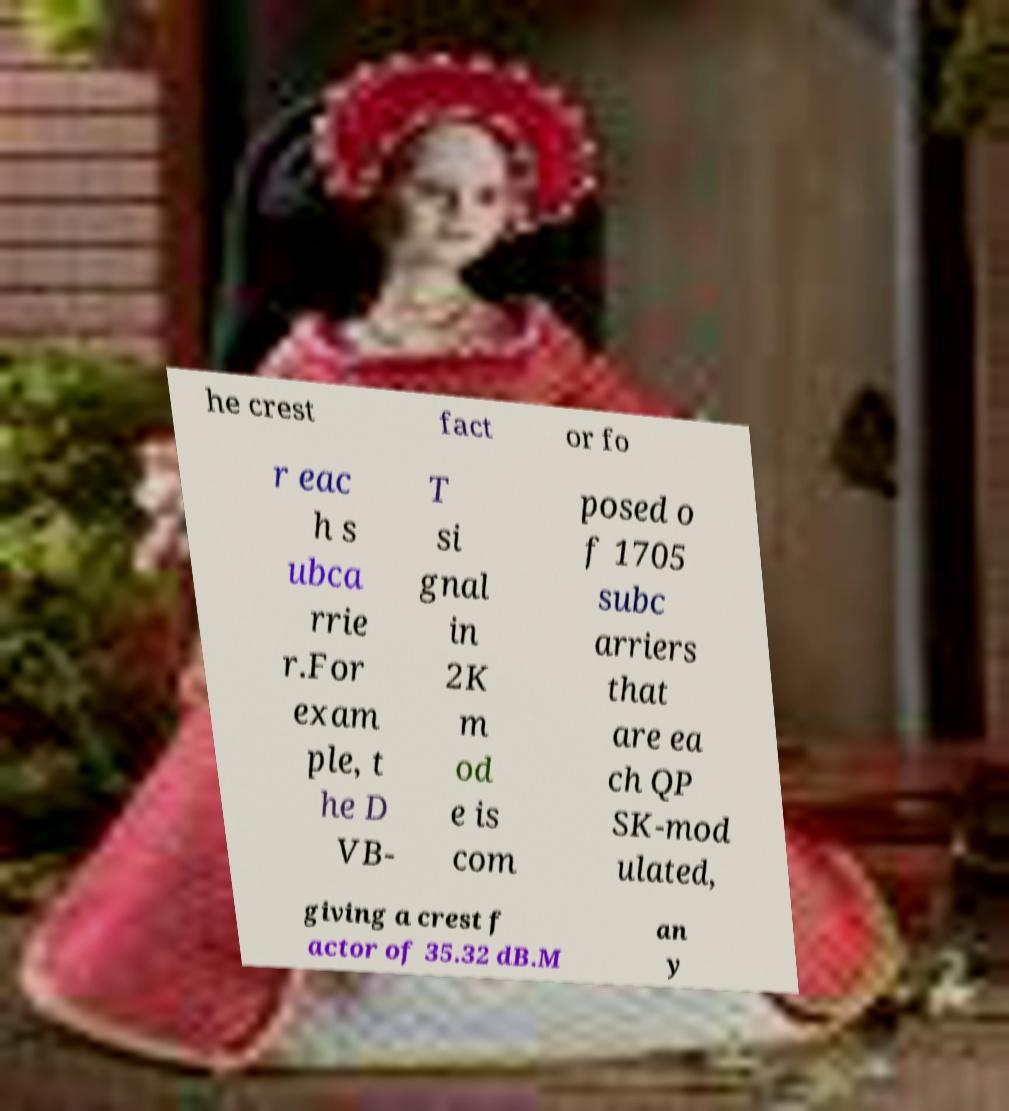Could you extract and type out the text from this image? he crest fact or fo r eac h s ubca rrie r.For exam ple, t he D VB- T si gnal in 2K m od e is com posed o f 1705 subc arriers that are ea ch QP SK-mod ulated, giving a crest f actor of 35.32 dB.M an y 